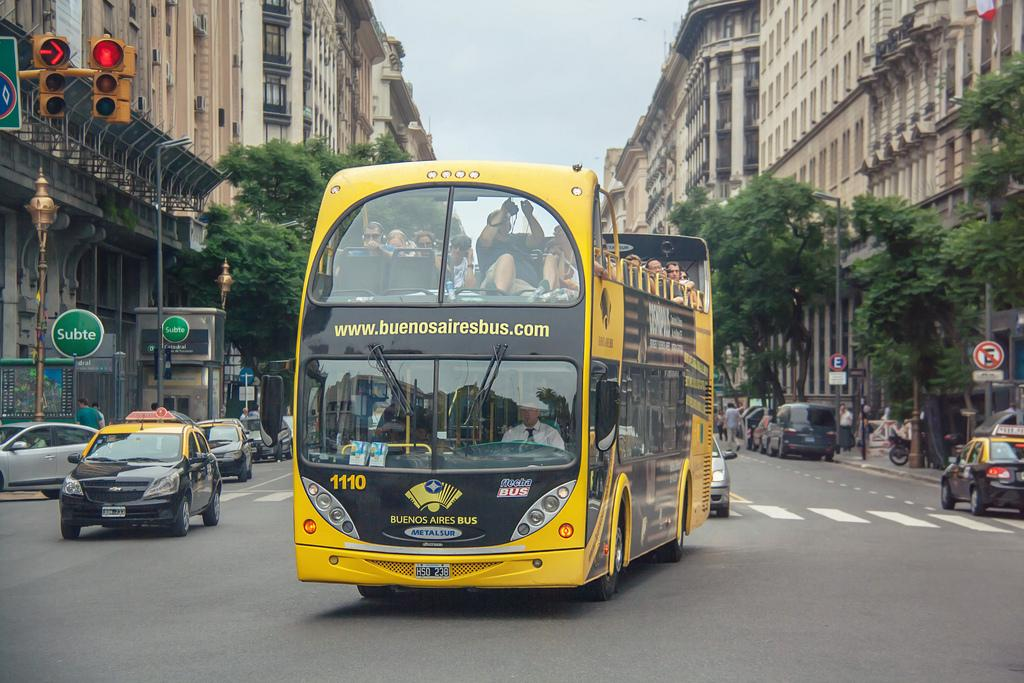What is happening on the street the tour bus is traveling on? The street has a grey surface, and there is a crosswalk and a red traffic signal. The bus is sharing the road with a black and yellow car. What type of vehicle is prominently featured in the image, and what is its purpose? A yellow double decker tour bus is prominently featured, which is used for touring the city. Select a prominent object in the image and describe its position and appearance. The upper deck windshield of the tour bus is in the top-left corner and is about 285 pixels wide and 285 pixels tall. Can you see any elements of weather in the image? If so, describe them. Yes, there are white clouds in the blue sky seen at multiple locations in the image. List three features of the tour bus that are visible in the image. The driver's front windshield, front headlight, and upper deck windshield of the tour bus are visible in the image. Describe the traffic-related items present in the scene. There are traffic lights mounted over the city street, street lights on the side of the road, traffic signs on the street curb, and a traffic signal displaying a red light. Identify the primary mode of transportation in the image along with its color. The primary mode of transportation is a yellow double decker tour bus in the city. What type of image analysis tasks would be appropriate for this dataset? VQA (Visual Question Answering), image segmentation, image anomaly detection, image context analysis, image sentiment analysis, and complex reasoning tasks. What elements can be seen above the city street in the image? traffic lights and street lights What are the elements visible above the street in the image? traffic lights, street lights, blue sky, white clouds List the objects visible in the sky. white clouds, blue sky What vehicle can be seen in the image? yellow double decker tour bus Which direction is the red arrow pointing? Answer:  Do you notice the green bike parked on the right-hand side of the road? There is no mention of any green bike or bikes parked in the image. By asking a question about a nonexistent object, this instruction is misleading. Which part of the car is visible in the picture? side What is the surface color of the street? grey List all objects found on the curb in the image. traffic signs Describe the color and type of the car in the image. black and yellow car Can you spot the pink elephant next to the bus? It's really cute. No, it's not mentioned in the image. What type of vehicle is the main subject of the image? double decker tour bus A group of tourists is standing next to the bus, waiting to board for the tour. There is no mention of any tourists in the image, so this statement misleads the viewer by implying that people are present in the scene. Can you find the giant billboard advertisement promoting a famous soda brand? No billboard advertisement is mentioned in the image, so this question is misleading as it refers to a nonexistent object. Look for the orange hot air balloon floating in the sky on the top right corner of the image. There is no hot air balloon mentioned in the image, and the only objects in the sky are the white clouds, making this instruction entirely misleading. Explain the state of the traffic signal in the image. the red light is on There is a blue car with a dent on its hood behind the black and yellow car. The only car described in the image is the black and yellow car. No blue car is mentioned, making this statement misleading and inaccurate. Specify the colors visible in the sky. blue and white Describe the traffic signal in the image. red signal light on, mounted over the city street Identify the text visible on the tour bus. business brand name, identification number, license plate What is the color and type of vehicle present in the image? yellow double decker bus, black and.yellow car Is there a crosswalk visible in the image? Yes Describe the main object in the picture using colors, size, and purpose. shiny yellow large double deck bus for tours What are the elements found on the front of the tour bus? drivers front windshield, upper deck windshield, headlight, windshield wiper 